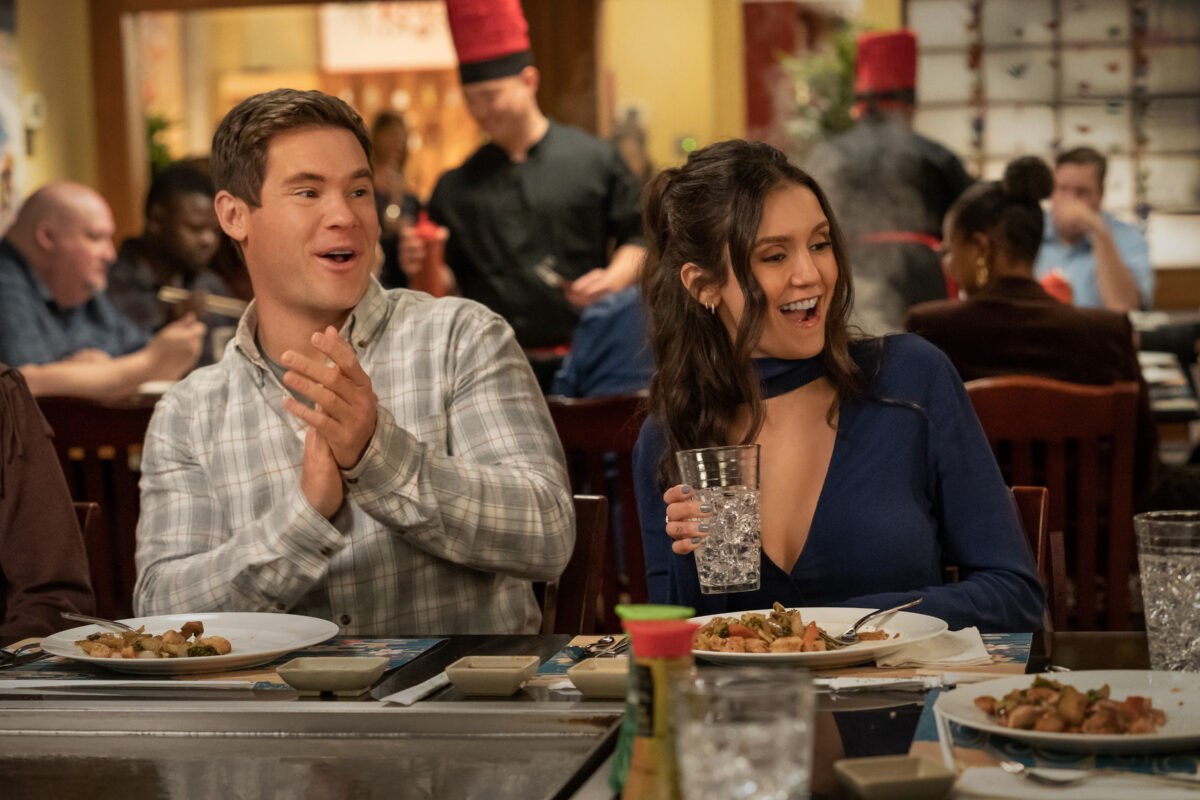What can you tell about the relationship between the two main subjects based on their expressions and body language? Their body language and expressions suggest a close and comfortable relationship, with genuine enjoyment in each other's company. The open smiles, direct eye contact, and relaxed postures indicate familiarity and a positive shared experience. Could you describe the atmosphere of the restaurant they are in? The restaurant has a warm and inviting atmosphere, with vibrant activity visible both in the background and foreground. The presence of a chef cooking on a grill and the variety of diners suggest a dynamic and interactive dining experience typical of a teppanyaki restaurant. 